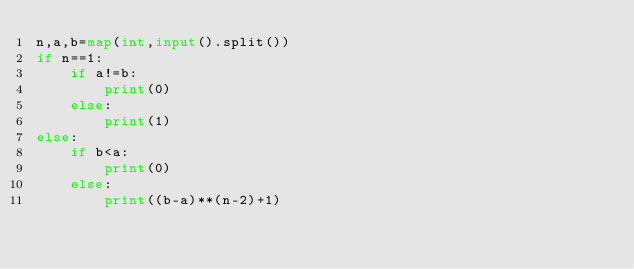Convert code to text. <code><loc_0><loc_0><loc_500><loc_500><_Python_>n,a,b=map(int,input().split())
if n==1:
    if a!=b:
        print(0)
    else:
        print(1)
else:
    if b<a:
        print(0)
    else:
        print((b-a)**(n-2)+1)</code> 